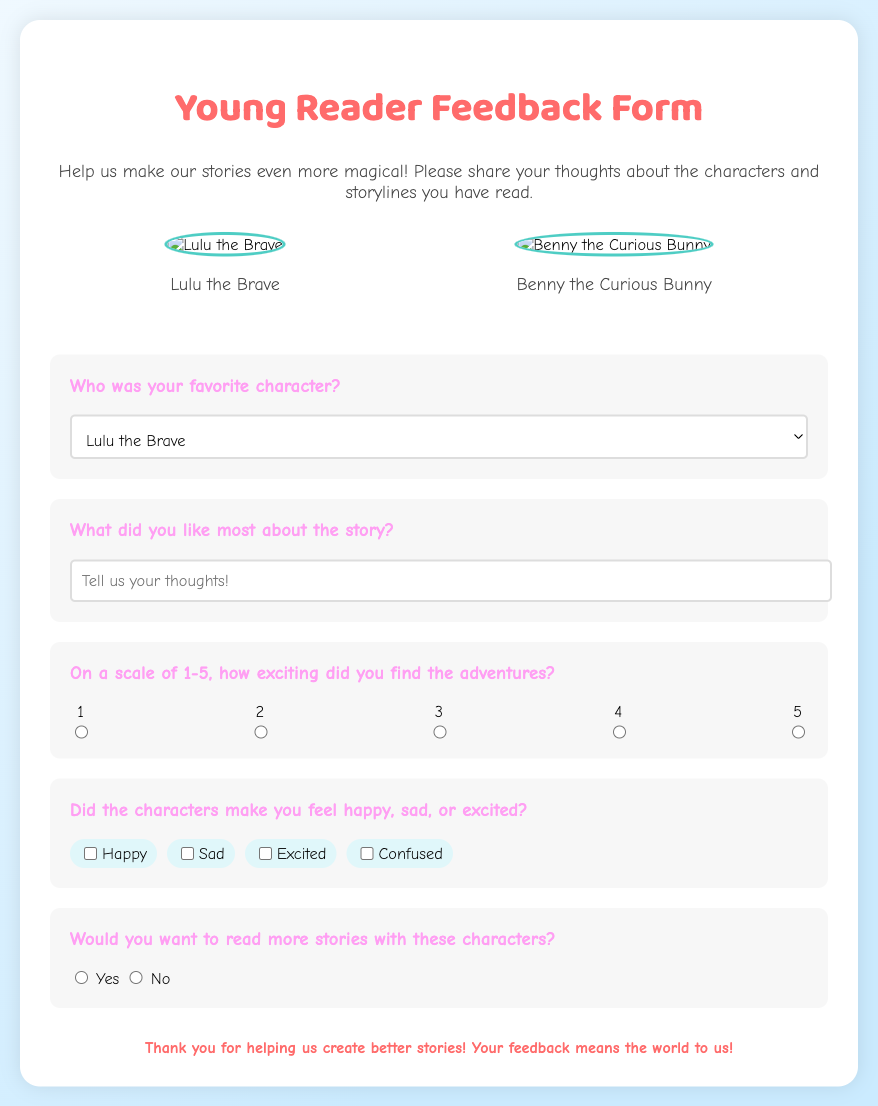What is the title of the feedback form? The title is prominently displayed at the top of the document, identifying the purpose of the form.
Answer: Young Reader Feedback Form How many characters are featured in the feedback form? The feedback form displays images and names of two characters in the characters section.
Answer: 2 What is the name of the character represented by the second image? The second character's name is shown below the corresponding image in the characters section.
Answer: Benny the Curious Bunny What scale is used to rate the excitement of the adventures? The document specifies a range for rating excitement in a clear and simple format.
Answer: 1-5 What can readers select as an option for expressing their feelings about the characters? The document provides multiple feelings in a checkbox format, allowing readers to select their responses.
Answer: Happy, Sad, Excited, Confused What is the background color gradient of the feedback form? The visual appearance of the document includes a color gradient, which adds to its design.
Answer: Light blue to light teal How does the feedback form show appreciation for responses? The document includes a thank-you message to express gratitude to the readers for their feedback.
Answer: Thank you for helping us create better stories! 